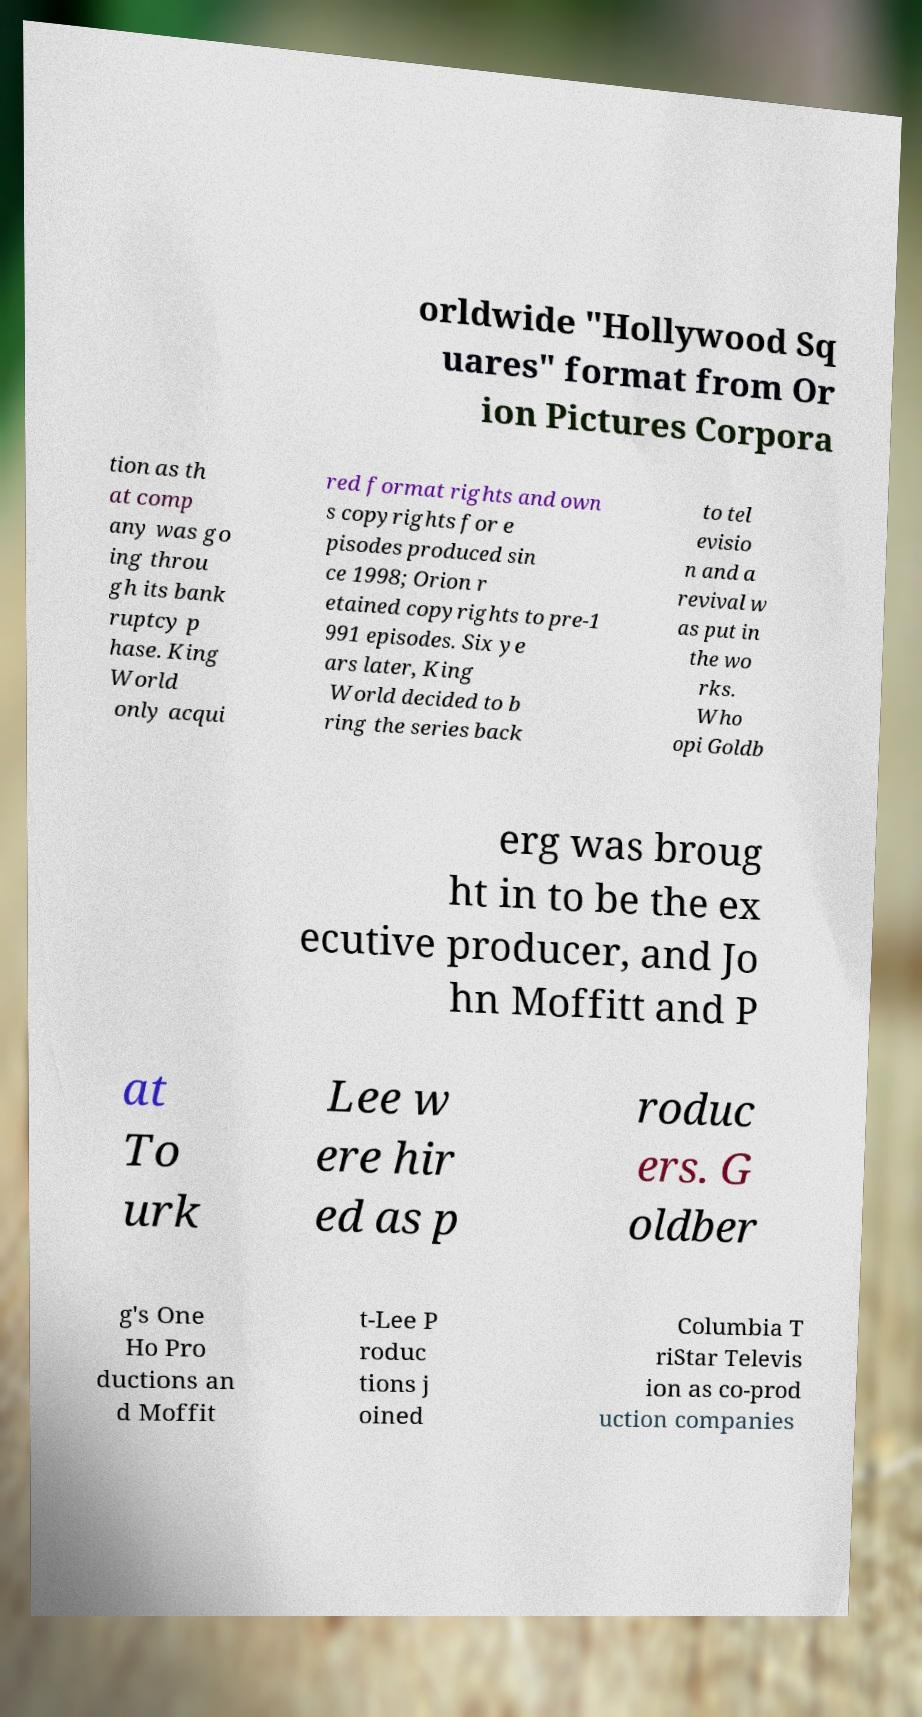Could you extract and type out the text from this image? orldwide "Hollywood Sq uares" format from Or ion Pictures Corpora tion as th at comp any was go ing throu gh its bank ruptcy p hase. King World only acqui red format rights and own s copyrights for e pisodes produced sin ce 1998; Orion r etained copyrights to pre-1 991 episodes. Six ye ars later, King World decided to b ring the series back to tel evisio n and a revival w as put in the wo rks. Who opi Goldb erg was broug ht in to be the ex ecutive producer, and Jo hn Moffitt and P at To urk Lee w ere hir ed as p roduc ers. G oldber g's One Ho Pro ductions an d Moffit t-Lee P roduc tions j oined Columbia T riStar Televis ion as co-prod uction companies 